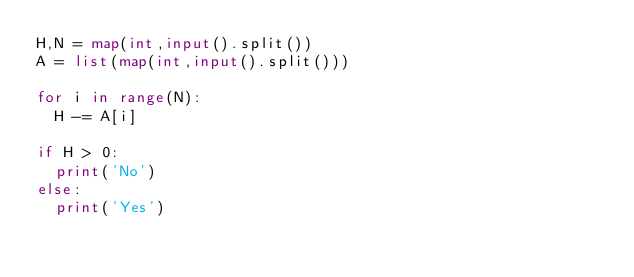Convert code to text. <code><loc_0><loc_0><loc_500><loc_500><_Python_>H,N = map(int,input().split())
A = list(map(int,input().split()))

for i in range(N):
  H -= A[i]

if H > 0:
  print('No')
else:
  print('Yes')</code> 